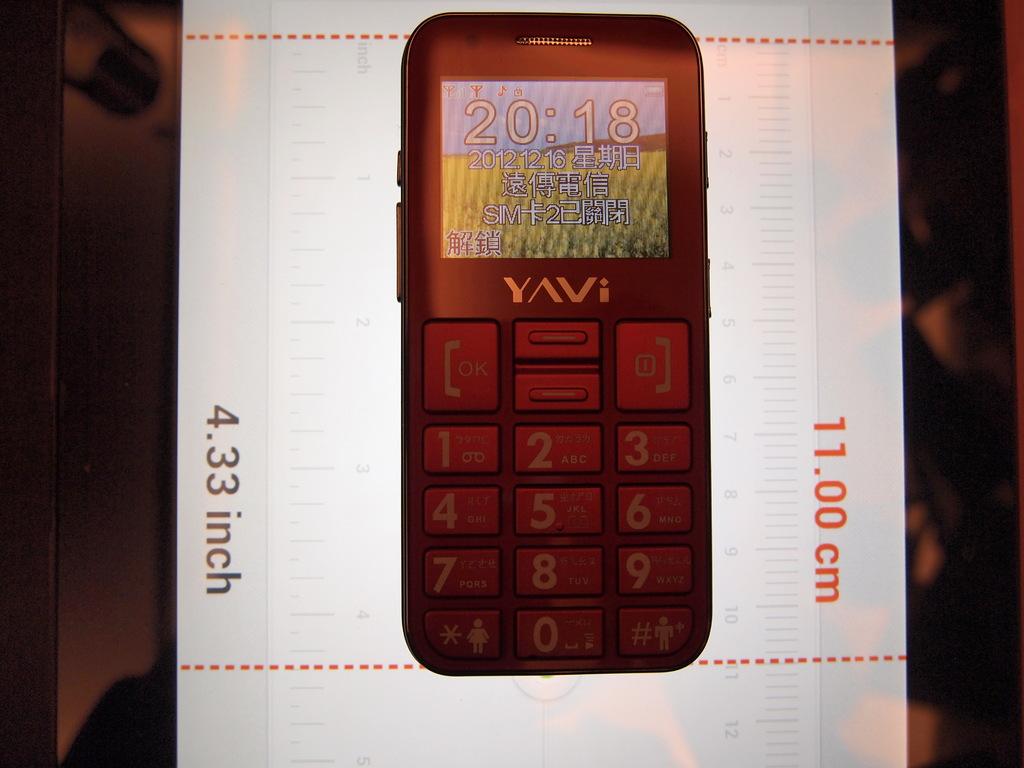How many inches is the phone?
Provide a short and direct response. 4.33. How many cm is this phone?
Offer a terse response. 11. 